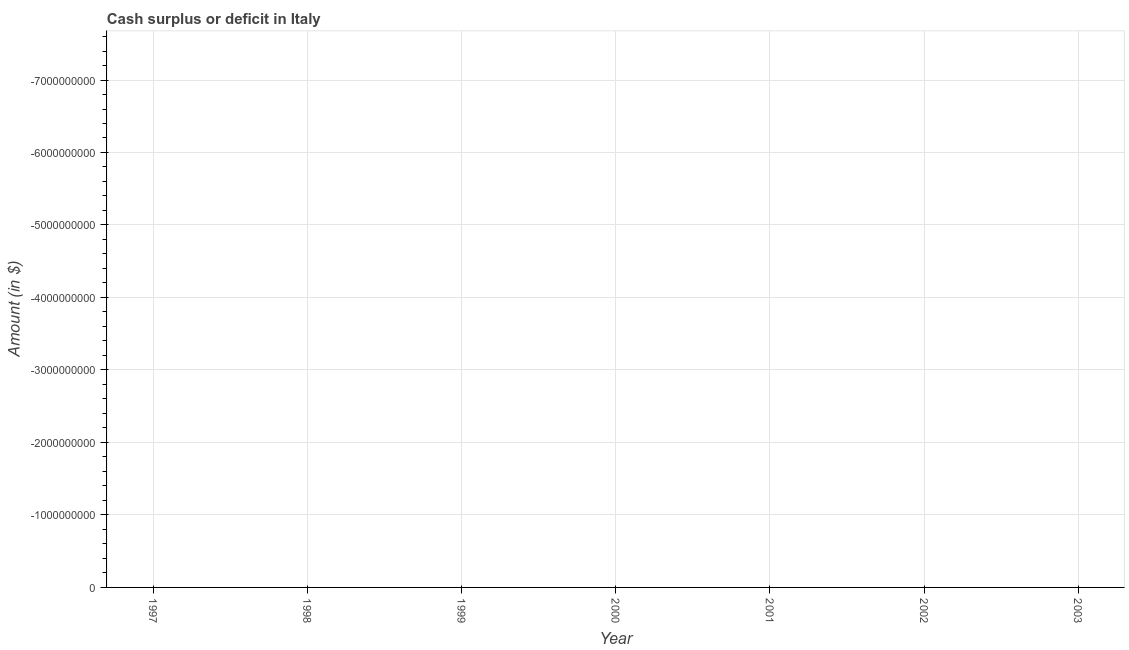What is the cash surplus or deficit in 1999?
Your answer should be very brief. 0. In how many years, is the cash surplus or deficit greater than -2800000000 $?
Your answer should be compact. 0. How many years are there in the graph?
Make the answer very short. 7. Does the graph contain grids?
Make the answer very short. Yes. What is the title of the graph?
Your answer should be very brief. Cash surplus or deficit in Italy. What is the label or title of the Y-axis?
Provide a short and direct response. Amount (in $). What is the Amount (in $) in 1998?
Ensure brevity in your answer.  0. What is the Amount (in $) in 1999?
Your answer should be very brief. 0. What is the Amount (in $) in 2000?
Make the answer very short. 0. What is the Amount (in $) in 2002?
Your response must be concise. 0. What is the Amount (in $) in 2003?
Offer a very short reply. 0. 